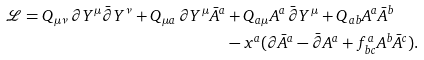<formula> <loc_0><loc_0><loc_500><loc_500>\mathcal { L } = Q _ { \mu \nu } \, \partial Y ^ { \mu } \bar { \partial } Y ^ { \nu } + Q _ { \mu a } \, \partial Y ^ { \mu } \bar { A } ^ { a } & + Q _ { a \mu } A ^ { a } \, \bar { \partial } Y ^ { \mu } + Q _ { a b } A ^ { a } \bar { A } ^ { b } \\ & - x ^ { a } ( \partial \bar { A } ^ { a } - \bar { \partial } A ^ { a } + f _ { b c } ^ { a } A ^ { b } \bar { A } ^ { c } ) .</formula> 